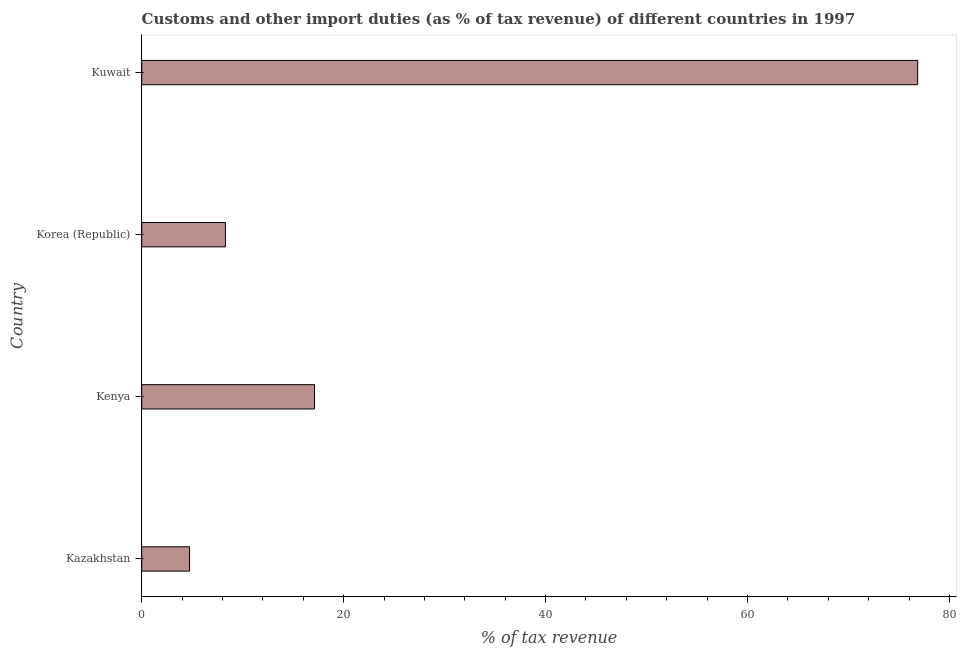What is the title of the graph?
Your response must be concise. Customs and other import duties (as % of tax revenue) of different countries in 1997. What is the label or title of the X-axis?
Your response must be concise. % of tax revenue. What is the customs and other import duties in Kazakhstan?
Provide a short and direct response. 4.74. Across all countries, what is the maximum customs and other import duties?
Ensure brevity in your answer.  76.85. Across all countries, what is the minimum customs and other import duties?
Offer a terse response. 4.74. In which country was the customs and other import duties maximum?
Give a very brief answer. Kuwait. In which country was the customs and other import duties minimum?
Keep it short and to the point. Kazakhstan. What is the sum of the customs and other import duties?
Your answer should be very brief. 106.99. What is the difference between the customs and other import duties in Korea (Republic) and Kuwait?
Your response must be concise. -68.56. What is the average customs and other import duties per country?
Your answer should be compact. 26.75. What is the median customs and other import duties?
Ensure brevity in your answer.  12.7. In how many countries, is the customs and other import duties greater than 60 %?
Provide a short and direct response. 1. What is the ratio of the customs and other import duties in Korea (Republic) to that in Kuwait?
Keep it short and to the point. 0.11. Is the customs and other import duties in Kenya less than that in Korea (Republic)?
Provide a succinct answer. No. Is the difference between the customs and other import duties in Kazakhstan and Kenya greater than the difference between any two countries?
Give a very brief answer. No. What is the difference between the highest and the second highest customs and other import duties?
Your response must be concise. 59.74. Is the sum of the customs and other import duties in Kenya and Korea (Republic) greater than the maximum customs and other import duties across all countries?
Provide a short and direct response. No. What is the difference between the highest and the lowest customs and other import duties?
Offer a very short reply. 72.12. In how many countries, is the customs and other import duties greater than the average customs and other import duties taken over all countries?
Keep it short and to the point. 1. Are all the bars in the graph horizontal?
Provide a succinct answer. Yes. How many countries are there in the graph?
Your response must be concise. 4. What is the difference between two consecutive major ticks on the X-axis?
Keep it short and to the point. 20. Are the values on the major ticks of X-axis written in scientific E-notation?
Keep it short and to the point. No. What is the % of tax revenue of Kazakhstan?
Ensure brevity in your answer.  4.74. What is the % of tax revenue in Kenya?
Make the answer very short. 17.11. What is the % of tax revenue of Korea (Republic)?
Your answer should be compact. 8.29. What is the % of tax revenue of Kuwait?
Offer a terse response. 76.85. What is the difference between the % of tax revenue in Kazakhstan and Kenya?
Ensure brevity in your answer.  -12.38. What is the difference between the % of tax revenue in Kazakhstan and Korea (Republic)?
Offer a very short reply. -3.56. What is the difference between the % of tax revenue in Kazakhstan and Kuwait?
Your response must be concise. -72.12. What is the difference between the % of tax revenue in Kenya and Korea (Republic)?
Keep it short and to the point. 8.82. What is the difference between the % of tax revenue in Kenya and Kuwait?
Provide a succinct answer. -59.74. What is the difference between the % of tax revenue in Korea (Republic) and Kuwait?
Offer a terse response. -68.56. What is the ratio of the % of tax revenue in Kazakhstan to that in Kenya?
Provide a succinct answer. 0.28. What is the ratio of the % of tax revenue in Kazakhstan to that in Korea (Republic)?
Provide a short and direct response. 0.57. What is the ratio of the % of tax revenue in Kazakhstan to that in Kuwait?
Your response must be concise. 0.06. What is the ratio of the % of tax revenue in Kenya to that in Korea (Republic)?
Offer a terse response. 2.06. What is the ratio of the % of tax revenue in Kenya to that in Kuwait?
Offer a terse response. 0.22. What is the ratio of the % of tax revenue in Korea (Republic) to that in Kuwait?
Keep it short and to the point. 0.11. 